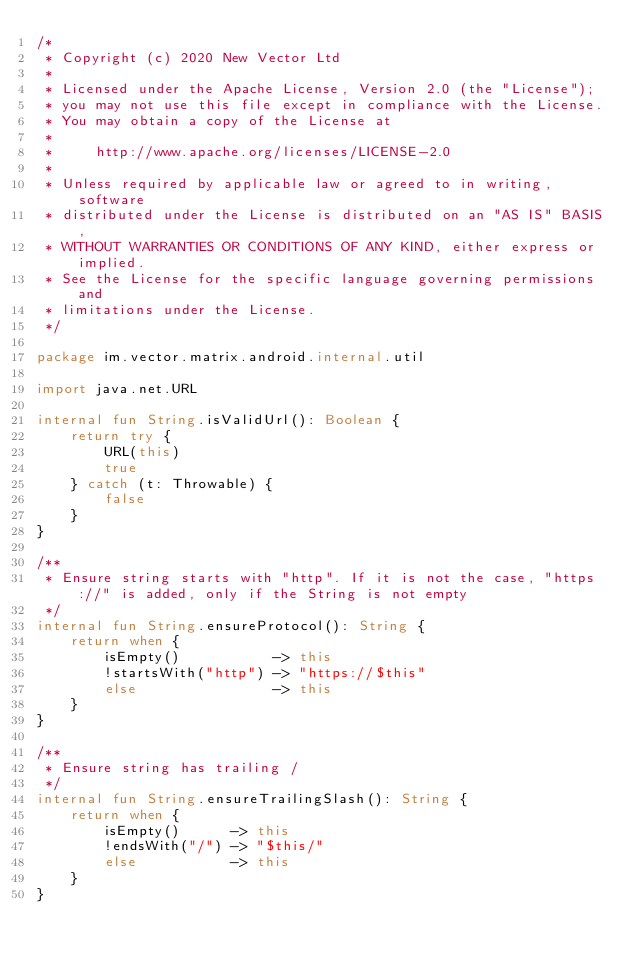<code> <loc_0><loc_0><loc_500><loc_500><_Kotlin_>/*
 * Copyright (c) 2020 New Vector Ltd
 *
 * Licensed under the Apache License, Version 2.0 (the "License");
 * you may not use this file except in compliance with the License.
 * You may obtain a copy of the License at
 *
 *     http://www.apache.org/licenses/LICENSE-2.0
 *
 * Unless required by applicable law or agreed to in writing, software
 * distributed under the License is distributed on an "AS IS" BASIS,
 * WITHOUT WARRANTIES OR CONDITIONS OF ANY KIND, either express or implied.
 * See the License for the specific language governing permissions and
 * limitations under the License.
 */

package im.vector.matrix.android.internal.util

import java.net.URL

internal fun String.isValidUrl(): Boolean {
    return try {
        URL(this)
        true
    } catch (t: Throwable) {
        false
    }
}

/**
 * Ensure string starts with "http". If it is not the case, "https://" is added, only if the String is not empty
 */
internal fun String.ensureProtocol(): String {
    return when {
        isEmpty()           -> this
        !startsWith("http") -> "https://$this"
        else                -> this
    }
}

/**
 * Ensure string has trailing /
 */
internal fun String.ensureTrailingSlash(): String {
    return when {
        isEmpty()      -> this
        !endsWith("/") -> "$this/"
        else           -> this
    }
}
</code> 